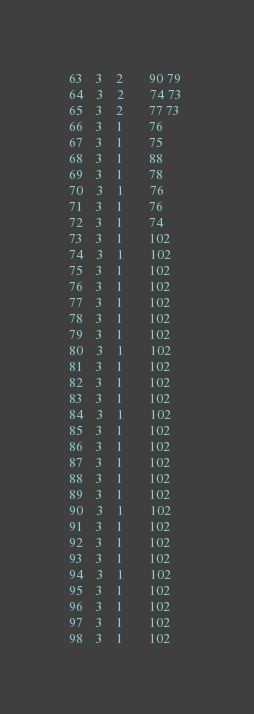Convert code to text. <code><loc_0><loc_0><loc_500><loc_500><_ObjectiveC_>63	3	2		90 79 
64	3	2		74 73 
65	3	2		77 73 
66	3	1		76 
67	3	1		75 
68	3	1		88 
69	3	1		78 
70	3	1		76 
71	3	1		76 
72	3	1		74 
73	3	1		102 
74	3	1		102 
75	3	1		102 
76	3	1		102 
77	3	1		102 
78	3	1		102 
79	3	1		102 
80	3	1		102 
81	3	1		102 
82	3	1		102 
83	3	1		102 
84	3	1		102 
85	3	1		102 
86	3	1		102 
87	3	1		102 
88	3	1		102 
89	3	1		102 
90	3	1		102 
91	3	1		102 
92	3	1		102 
93	3	1		102 
94	3	1		102 
95	3	1		102 
96	3	1		102 
97	3	1		102 
98	3	1		102 </code> 